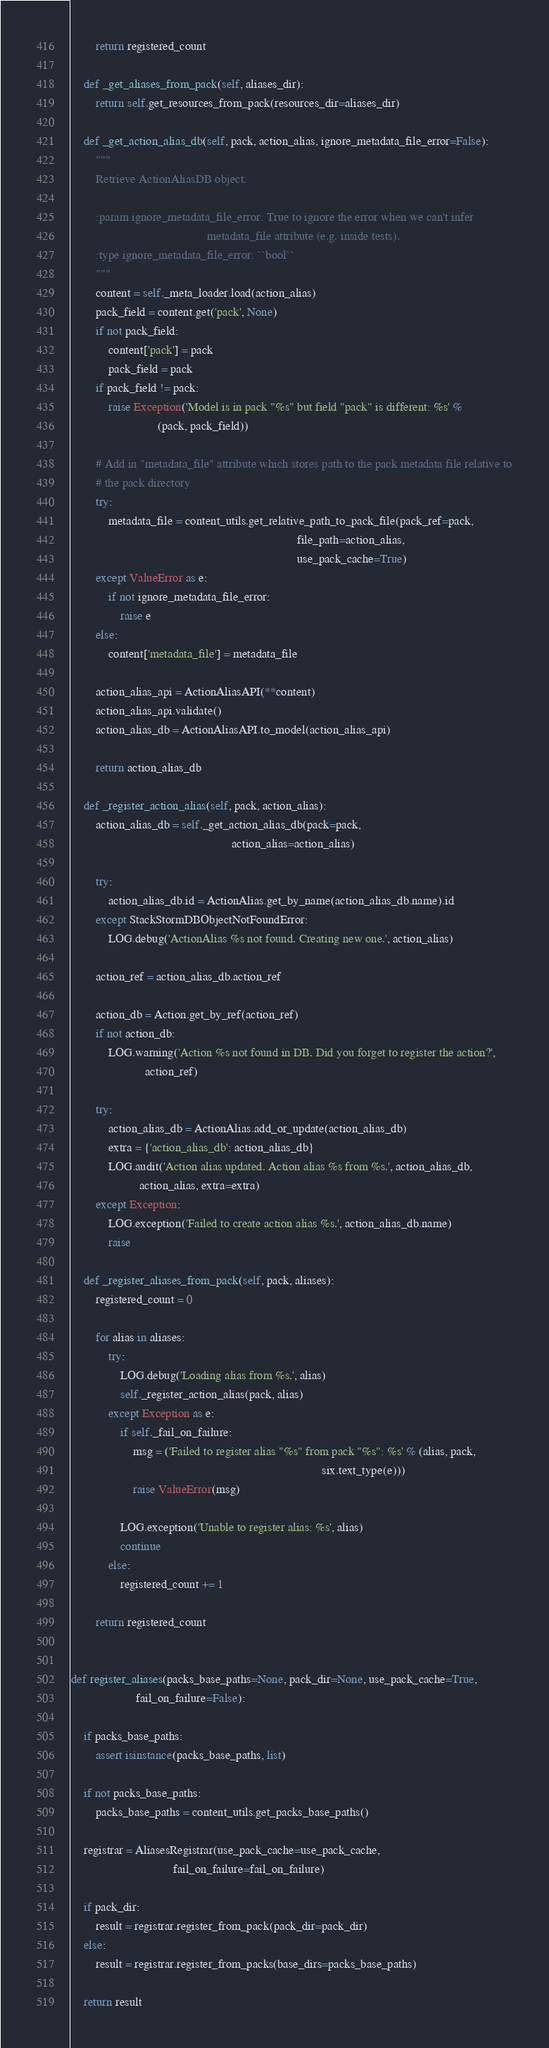<code> <loc_0><loc_0><loc_500><loc_500><_Python_>
        return registered_count

    def _get_aliases_from_pack(self, aliases_dir):
        return self.get_resources_from_pack(resources_dir=aliases_dir)

    def _get_action_alias_db(self, pack, action_alias, ignore_metadata_file_error=False):
        """
        Retrieve ActionAliasDB object.

        :param ignore_metadata_file_error: True to ignore the error when we can't infer
                                            metadata_file attribute (e.g. inside tests).
        :type ignore_metadata_file_error: ``bool``
        """
        content = self._meta_loader.load(action_alias)
        pack_field = content.get('pack', None)
        if not pack_field:
            content['pack'] = pack
            pack_field = pack
        if pack_field != pack:
            raise Exception('Model is in pack "%s" but field "pack" is different: %s' %
                            (pack, pack_field))

        # Add in "metadata_file" attribute which stores path to the pack metadata file relative to
        # the pack directory
        try:
            metadata_file = content_utils.get_relative_path_to_pack_file(pack_ref=pack,
                                                                         file_path=action_alias,
                                                                         use_pack_cache=True)
        except ValueError as e:
            if not ignore_metadata_file_error:
                raise e
        else:
            content['metadata_file'] = metadata_file

        action_alias_api = ActionAliasAPI(**content)
        action_alias_api.validate()
        action_alias_db = ActionAliasAPI.to_model(action_alias_api)

        return action_alias_db

    def _register_action_alias(self, pack, action_alias):
        action_alias_db = self._get_action_alias_db(pack=pack,
                                                    action_alias=action_alias)

        try:
            action_alias_db.id = ActionAlias.get_by_name(action_alias_db.name).id
        except StackStormDBObjectNotFoundError:
            LOG.debug('ActionAlias %s not found. Creating new one.', action_alias)

        action_ref = action_alias_db.action_ref

        action_db = Action.get_by_ref(action_ref)
        if not action_db:
            LOG.warning('Action %s not found in DB. Did you forget to register the action?',
                        action_ref)

        try:
            action_alias_db = ActionAlias.add_or_update(action_alias_db)
            extra = {'action_alias_db': action_alias_db}
            LOG.audit('Action alias updated. Action alias %s from %s.', action_alias_db,
                      action_alias, extra=extra)
        except Exception:
            LOG.exception('Failed to create action alias %s.', action_alias_db.name)
            raise

    def _register_aliases_from_pack(self, pack, aliases):
        registered_count = 0

        for alias in aliases:
            try:
                LOG.debug('Loading alias from %s.', alias)
                self._register_action_alias(pack, alias)
            except Exception as e:
                if self._fail_on_failure:
                    msg = ('Failed to register alias "%s" from pack "%s": %s' % (alias, pack,
                                                                                 six.text_type(e)))
                    raise ValueError(msg)

                LOG.exception('Unable to register alias: %s', alias)
                continue
            else:
                registered_count += 1

        return registered_count


def register_aliases(packs_base_paths=None, pack_dir=None, use_pack_cache=True,
                     fail_on_failure=False):

    if packs_base_paths:
        assert isinstance(packs_base_paths, list)

    if not packs_base_paths:
        packs_base_paths = content_utils.get_packs_base_paths()

    registrar = AliasesRegistrar(use_pack_cache=use_pack_cache,
                                 fail_on_failure=fail_on_failure)

    if pack_dir:
        result = registrar.register_from_pack(pack_dir=pack_dir)
    else:
        result = registrar.register_from_packs(base_dirs=packs_base_paths)

    return result
</code> 